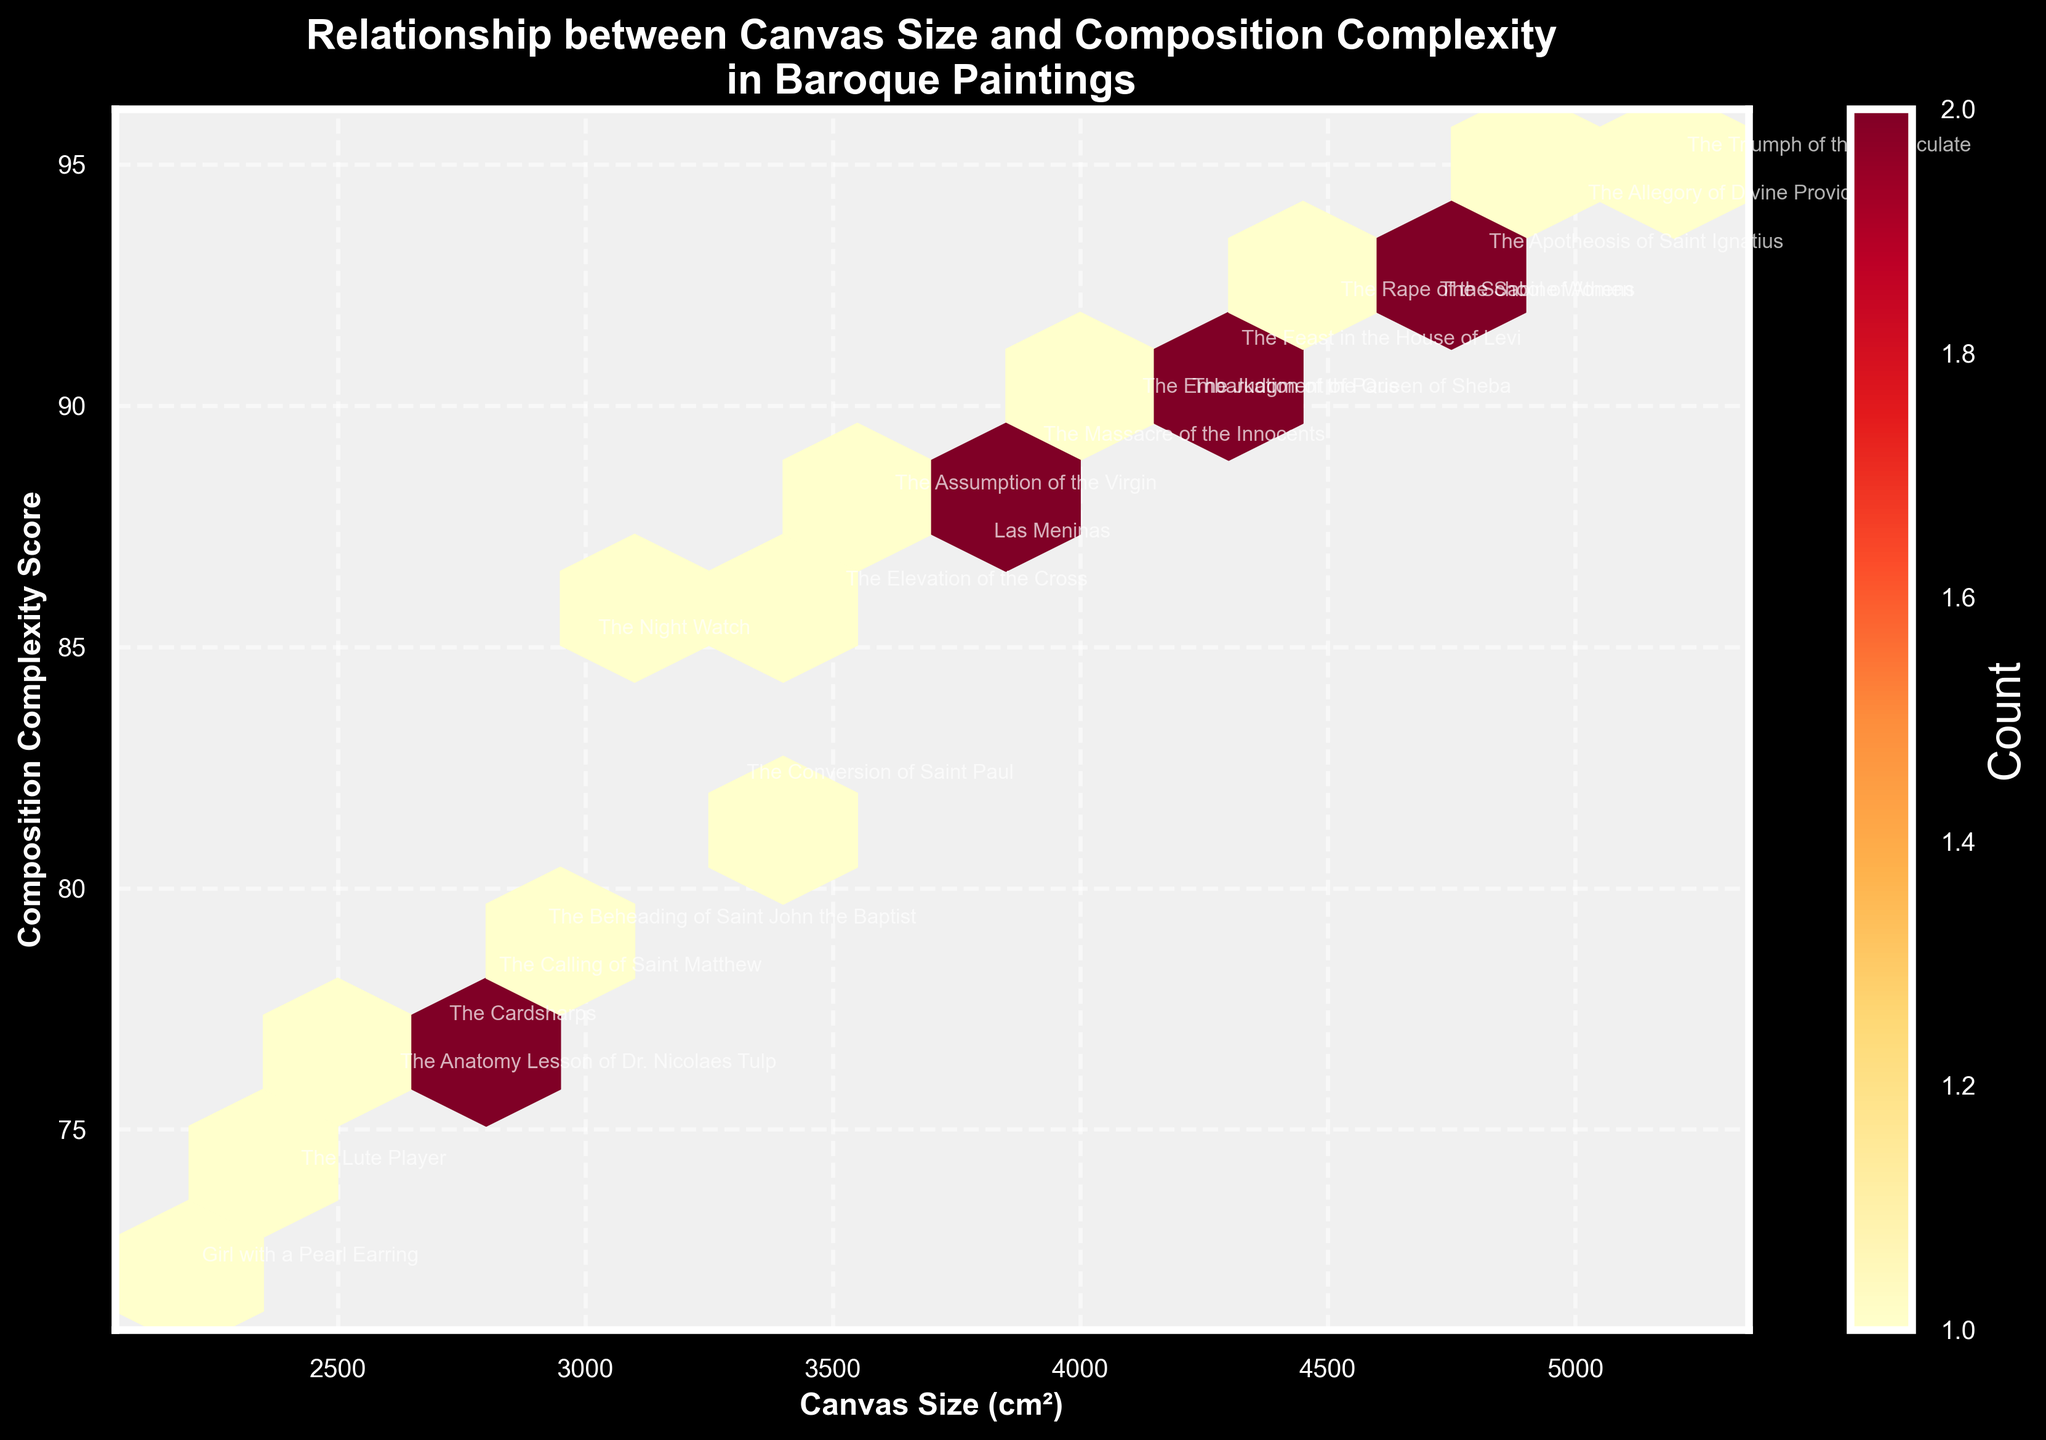What is the title of the plot? The title is usually located at the top center of the figure and summarizes the core message of the plot. In this case, it reads "Relationship between Canvas Size and Composition Complexity in Baroque Paintings".
Answer: Relationship between Canvas Size and Composition Complexity in Baroque Paintings How many data points have the maximum hexbin count? The color bar on the right indicates the counts of data points in each hexbin. Look for the darkest hexagon and use the color bar to determine its count.
Answer: 3 What are the labels of the x and y axes? The x-axis label is located at the bottom of the plot and signifies the independent variable–Canvas Size (cm²). The y-axis label is to the left of the plot and represents the dependent variable–Composition Complexity Score.
Answer: Canvas Size (cm²), Composition Complexity Score Among the labeled paintings, which has the highest composition complexity score? Locate the highest point on the y-axis (Composition Complexity Score) and identify the label of the painting closest to this point. In this case, it is "The Triumph of the Immaculate" by Paolo de Matteis with a score of 95.
Answer: The Triumph of the Immaculate What is the range of canvas sizes represented in the plot? The range can be determined by identifying the minimum and maximum values on the x-axis. It spans from the smallest canvas size to the largest on the x-axis.
Answer: 2200 to 5200 cm² Which artist has the most paintings represented in the plot? Count the frequency of each artist's name in the annotations. The artist with the highest count has the most paintings. Rembrandt appears twice.
Answer: Rembrandt Is there a general trend in the relationship between canvas size and composition complexity? Observe the overall distribution of hexagons. The pattern reveals whether larger canvases tend to have a higher complexity score or if there is no such relationship. In this plot, complexity seems to increase with canvas size.
Answer: Complexity tends to increase with canvas size Which painting with a canvas size around 3500 cm² has the lowest composition complexity score? Find the point around 3500 cm² on the x-axis and look vertically to locate the lowest point on the y-axis in that range. The painting "The Elevation of the Cross" by Peter Paul Rubens has a score of 86 at this canvas size.
Answer: The Elevation of the Cross What is the average composition complexity score for the paintings with canvas sizes between 3000 and 4000 cm²? Identify all points within the range of 3000 to 4000 cm² on the x-axis, sum their composition complexity scores, and divide by the number of points. The scores for these paintings are 78, 88, 82, 87, 89, 76, and 77, summing to 577; with 7 points, the average is 577/7 = 82.43.
Answer: 82.43 